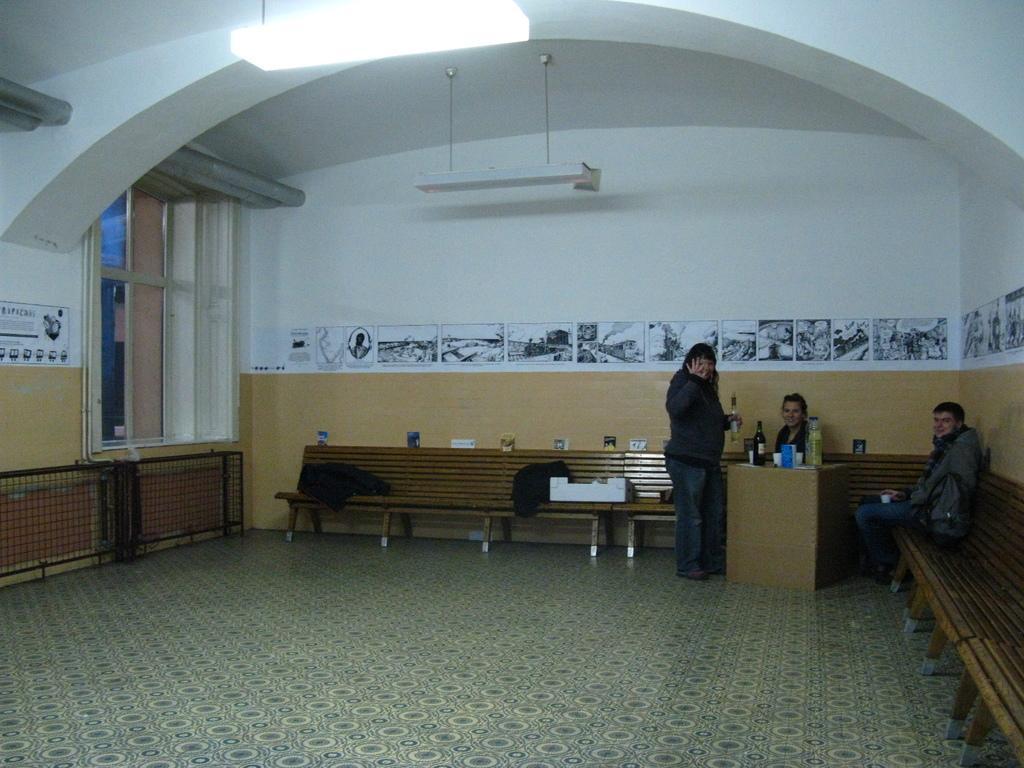Please provide a concise description of this image. Light is attached with the roof. This are windows. This is a bench, table. This 2 persons are sitting on a bench. This person is holding a bottle and wire jacket. On this table there is a cup and bottle. There are different type of posters on a wall. 